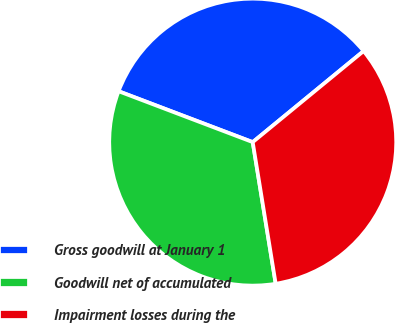Convert chart to OTSL. <chart><loc_0><loc_0><loc_500><loc_500><pie_chart><fcel>Gross goodwill at January 1<fcel>Goodwill net of accumulated<fcel>Impairment losses during the<nl><fcel>33.28%<fcel>33.33%<fcel>33.38%<nl></chart> 